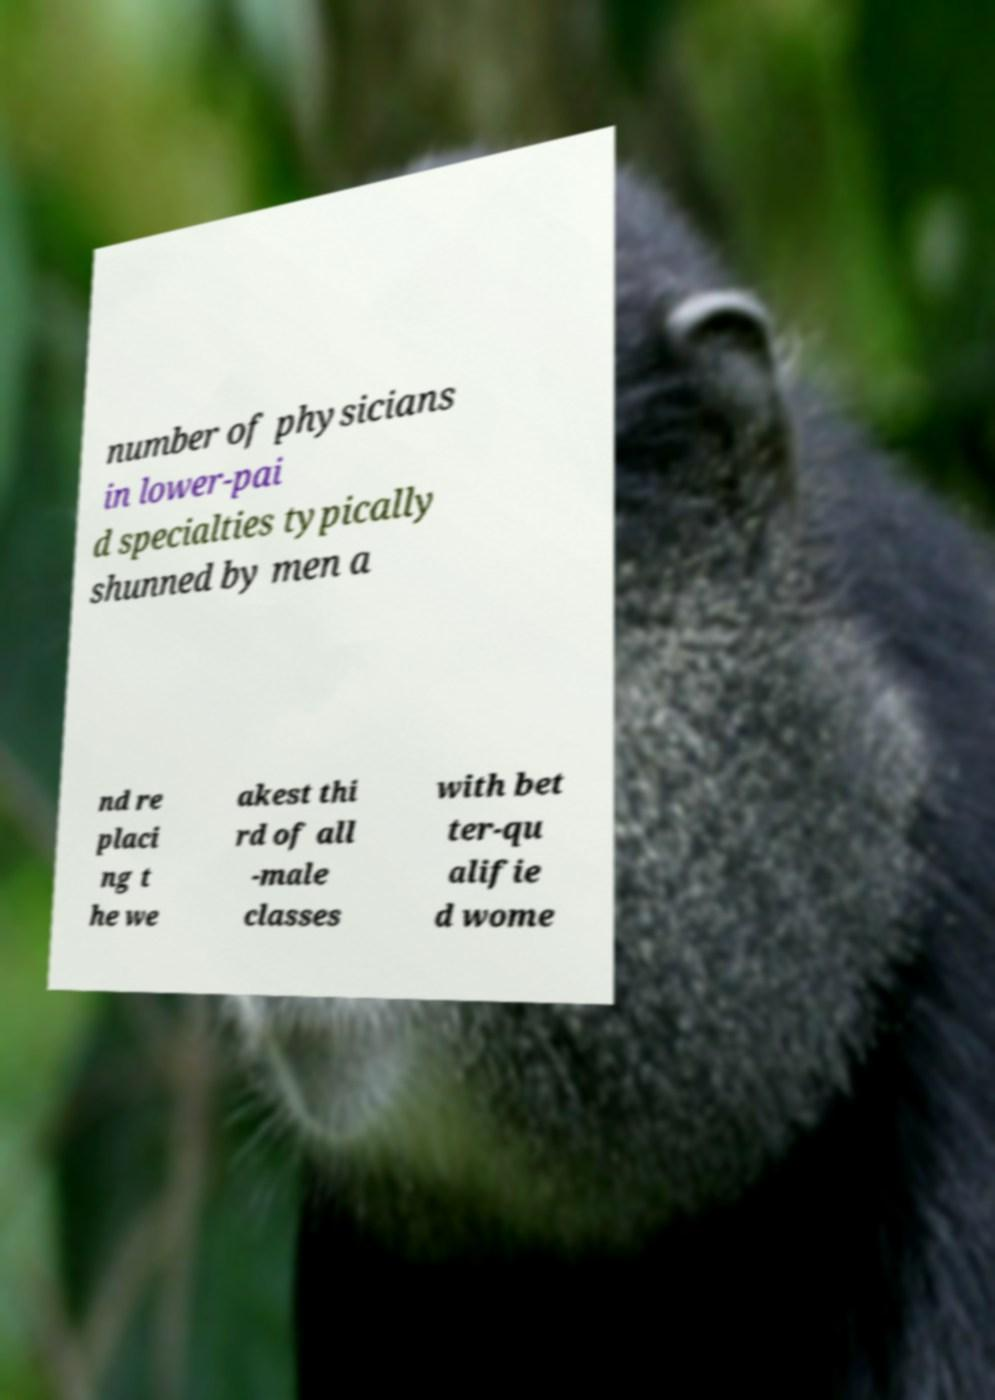Please read and relay the text visible in this image. What does it say? number of physicians in lower-pai d specialties typically shunned by men a nd re placi ng t he we akest thi rd of all -male classes with bet ter-qu alifie d wome 